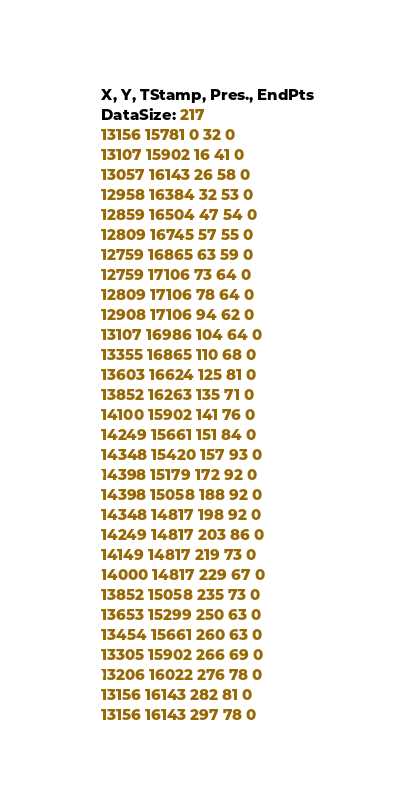Convert code to text. <code><loc_0><loc_0><loc_500><loc_500><_SML_>X, Y, TStamp, Pres., EndPts
DataSize: 217
13156 15781 0 32 0
13107 15902 16 41 0
13057 16143 26 58 0
12958 16384 32 53 0
12859 16504 47 54 0
12809 16745 57 55 0
12759 16865 63 59 0
12759 17106 73 64 0
12809 17106 78 64 0
12908 17106 94 62 0
13107 16986 104 64 0
13355 16865 110 68 0
13603 16624 125 81 0
13852 16263 135 71 0
14100 15902 141 76 0
14249 15661 151 84 0
14348 15420 157 93 0
14398 15179 172 92 0
14398 15058 188 92 0
14348 14817 198 92 0
14249 14817 203 86 0
14149 14817 219 73 0
14000 14817 229 67 0
13852 15058 235 73 0
13653 15299 250 63 0
13454 15661 260 63 0
13305 15902 266 69 0
13206 16022 276 78 0
13156 16143 282 81 0
13156 16143 297 78 0</code> 